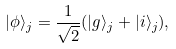Convert formula to latex. <formula><loc_0><loc_0><loc_500><loc_500>| \phi \rangle _ { j } = \frac { 1 } { \sqrt { 2 } } ( | g \rangle _ { j } + | i \rangle _ { j } ) ,</formula> 